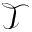Convert formula to latex. <formula><loc_0><loc_0><loc_500><loc_500>\mathcal { T }</formula> 